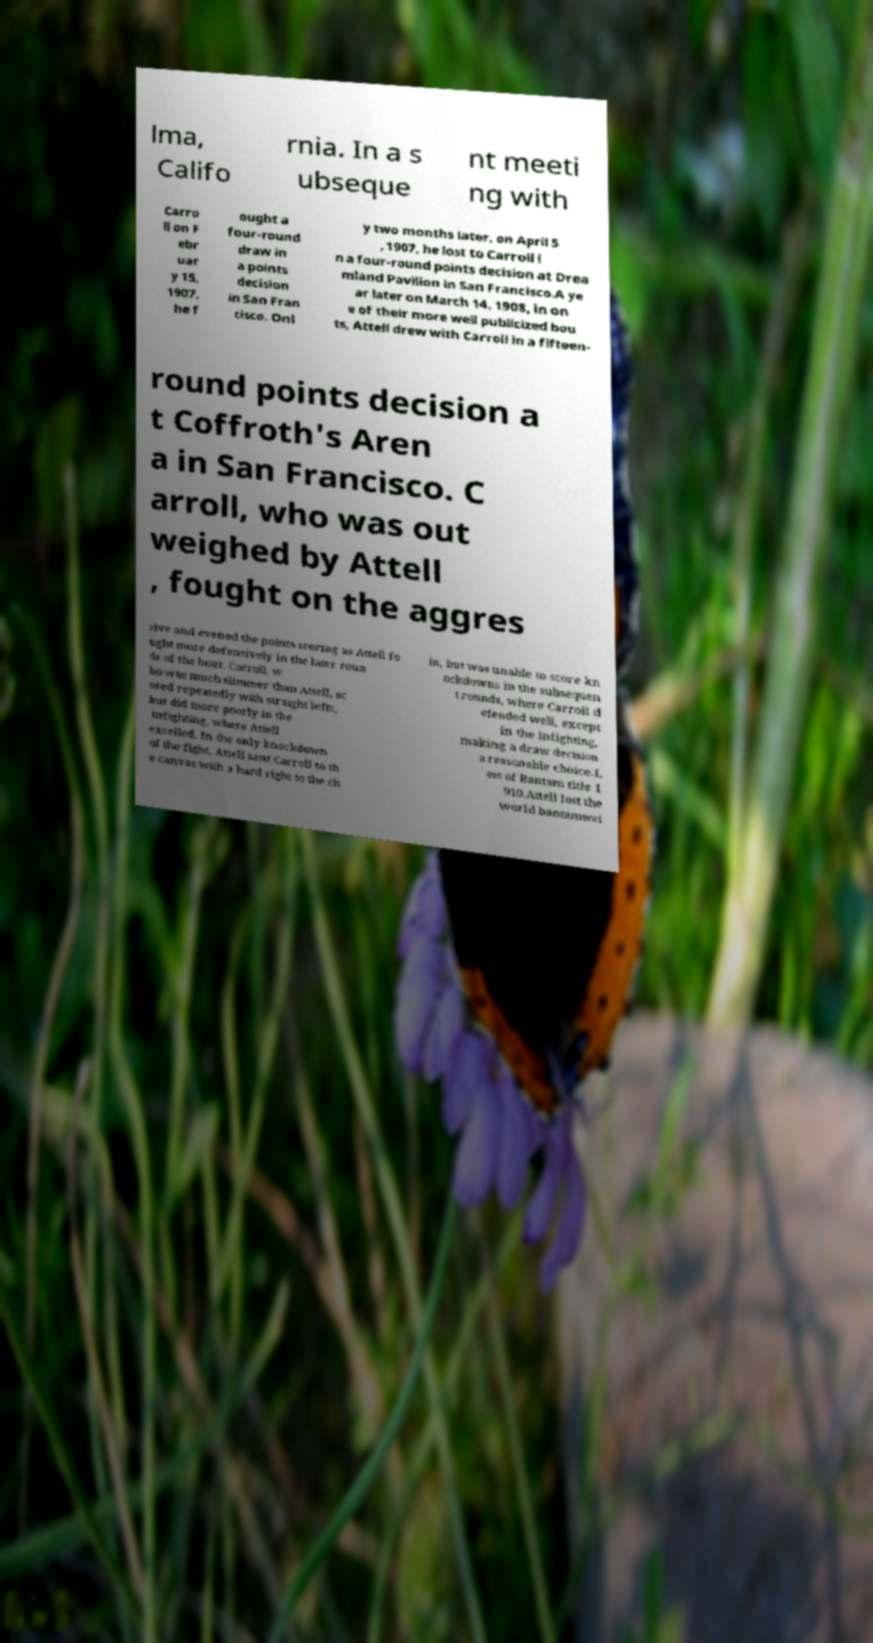Please read and relay the text visible in this image. What does it say? lma, Califo rnia. In a s ubseque nt meeti ng with Carro ll on F ebr uar y 15, 1907, he f ought a four-round draw in a points decision in San Fran cisco. Onl y two months later, on April 5 , 1907, he lost to Carroll i n a four-round points decision at Drea mland Pavilion in San Francisco.A ye ar later on March 14, 1908, in on e of their more well publicized bou ts, Attell drew with Carroll in a fifteen- round points decision a t Coffroth's Aren a in San Francisco. C arroll, who was out weighed by Attell , fought on the aggres sive and evened the points scoring as Attell fo ught more defensively in the later roun ds of the bout. Carroll, w ho was much slimmer than Attell, sc ored repeatedly with straight lefts, but did more poorly in the infighting, where Attell excelled. In the only knockdown of the fight, Attell sent Carroll to th e canvas with a hard right to the ch in, but was unable to score kn ockdowns in the subsequen t rounds, where Carroll d efended well, except in the infighting, making a draw decision a reasonable choice.L oss of Bantam title 1 910.Attell lost the world bantamwei 